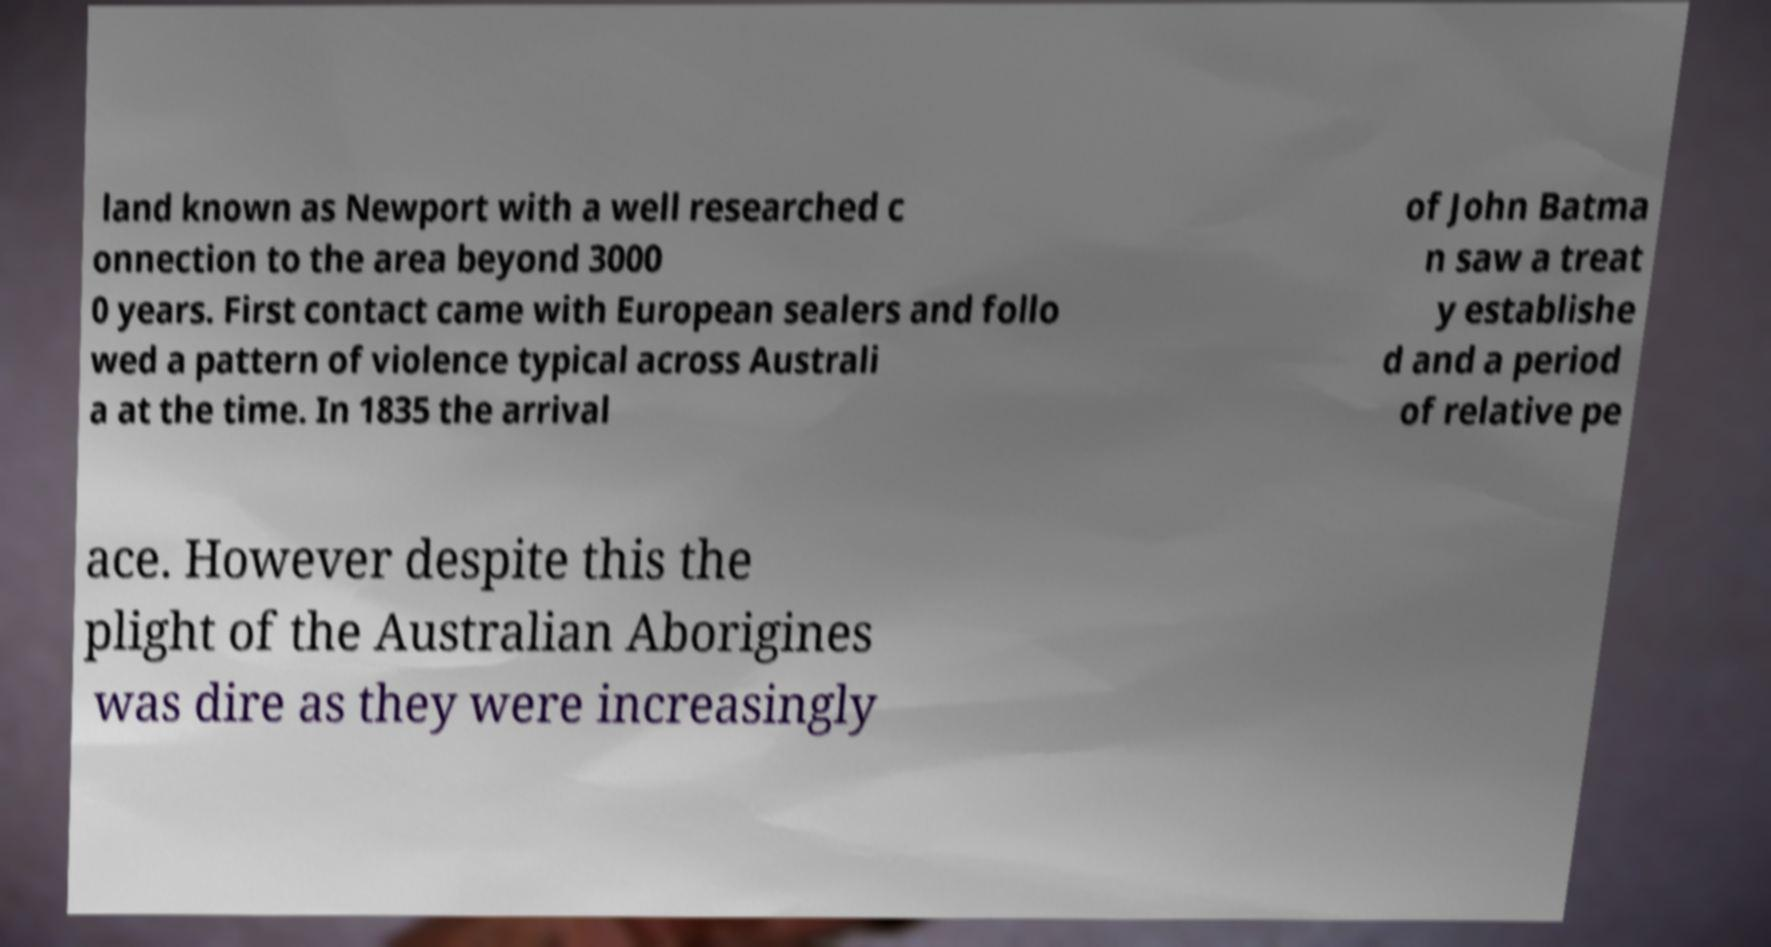Please identify and transcribe the text found in this image. land known as Newport with a well researched c onnection to the area beyond 3000 0 years. First contact came with European sealers and follo wed a pattern of violence typical across Australi a at the time. In 1835 the arrival of John Batma n saw a treat y establishe d and a period of relative pe ace. However despite this the plight of the Australian Aborigines was dire as they were increasingly 